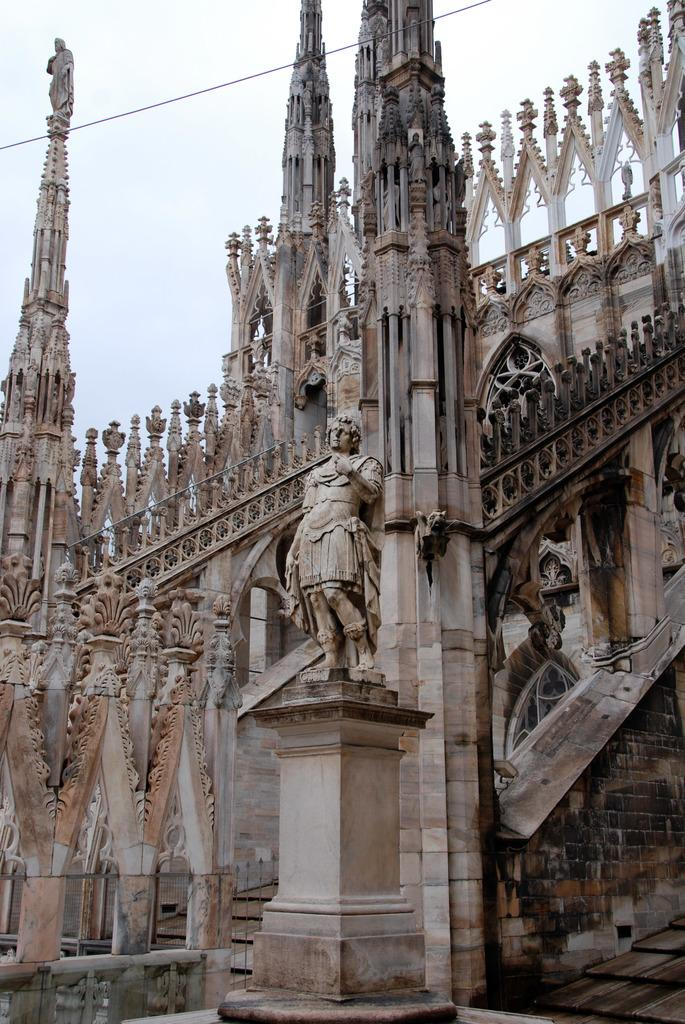What is located in the middle of the image? There is a building, towers, statues, and a wall in the middle of the image. Can you describe the sky in the image? The sky is visible at the top of the image. What type of wax can be seen melting in the middle of the image? There is no wax present in the image; it features a building, towers, statues, and a wall in the middle. 